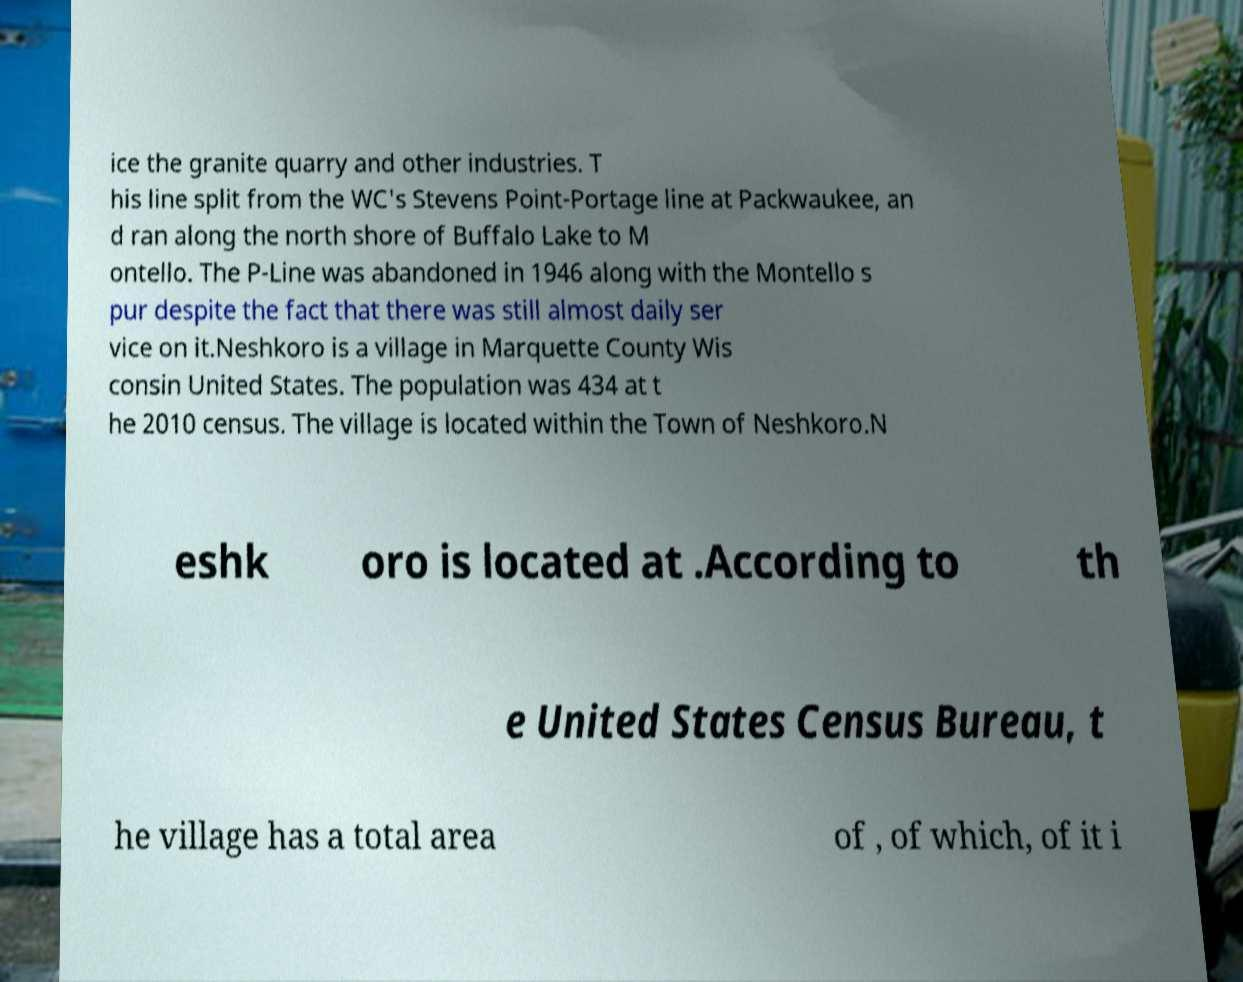Can you accurately transcribe the text from the provided image for me? ice the granite quarry and other industries. T his line split from the WC's Stevens Point-Portage line at Packwaukee, an d ran along the north shore of Buffalo Lake to M ontello. The P-Line was abandoned in 1946 along with the Montello s pur despite the fact that there was still almost daily ser vice on it.Neshkoro is a village in Marquette County Wis consin United States. The population was 434 at t he 2010 census. The village is located within the Town of Neshkoro.N eshk oro is located at .According to th e United States Census Bureau, t he village has a total area of , of which, of it i 